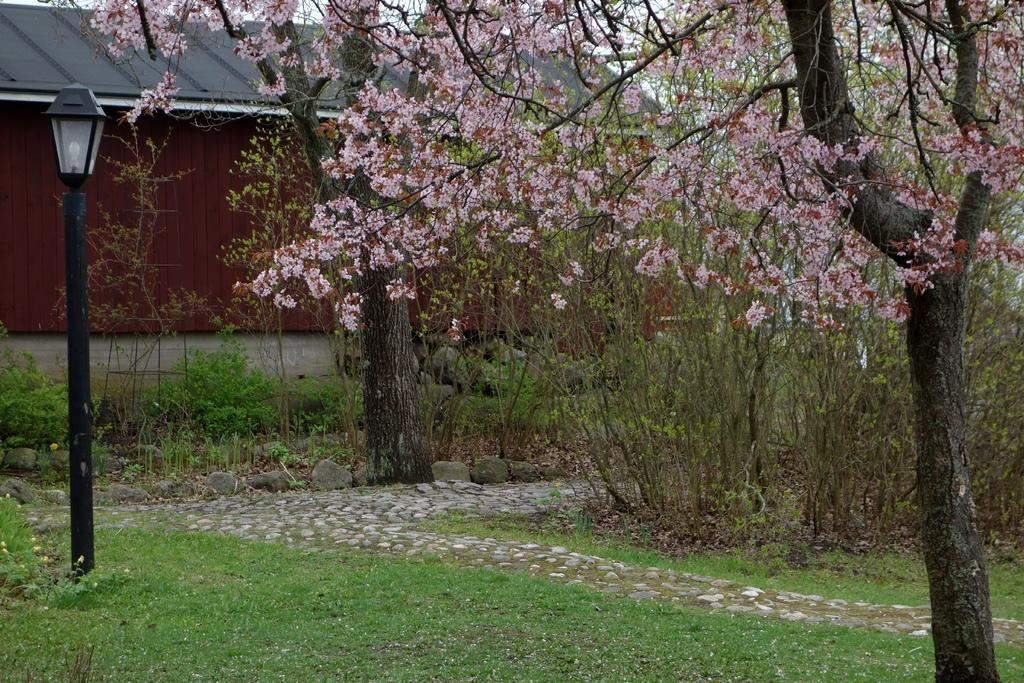What type of landscape is visible at the bottom of the image? There is grassland at the bottom side of the image. What structure can be seen on the left side of the image? There is a lamp pole on the left side of the image. What type of vegetation is present in the image? There are flower trees in the image. What type of building is visible in the image? There is a house in the image. How many children are playing on the trail in the image? There is no trail or children present in the image. 